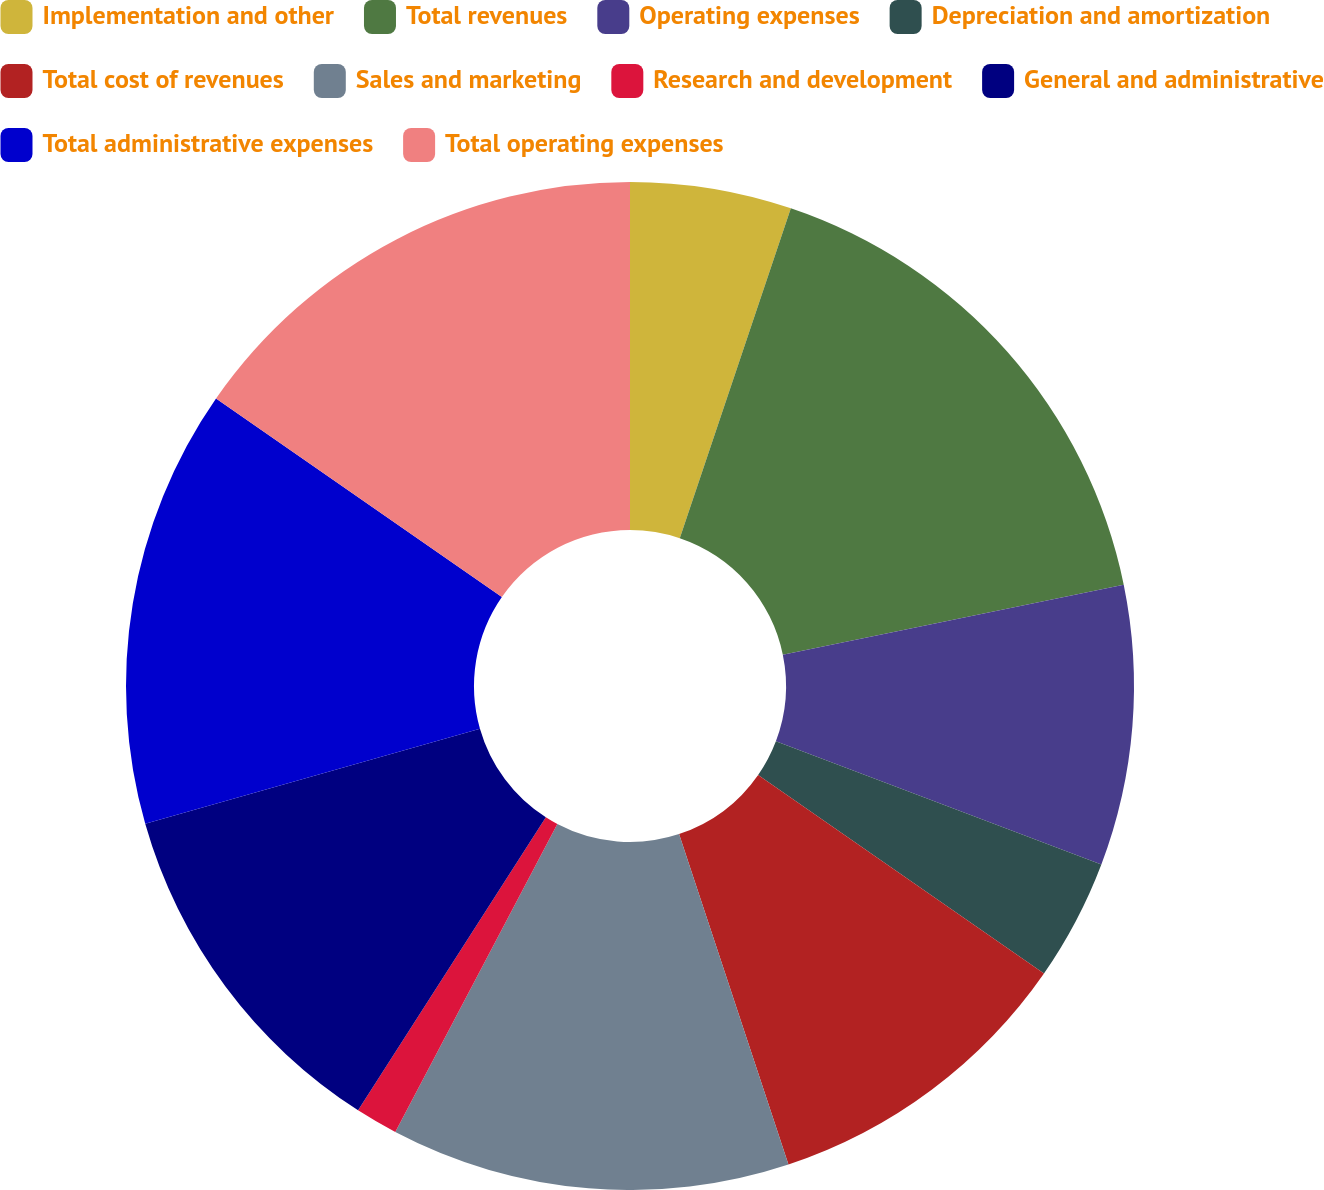Convert chart to OTSL. <chart><loc_0><loc_0><loc_500><loc_500><pie_chart><fcel>Implementation and other<fcel>Total revenues<fcel>Operating expenses<fcel>Depreciation and amortization<fcel>Total cost of revenues<fcel>Sales and marketing<fcel>Research and development<fcel>General and administrative<fcel>Total administrative expenses<fcel>Total operating expenses<nl><fcel>5.17%<fcel>16.61%<fcel>8.98%<fcel>3.9%<fcel>10.25%<fcel>12.8%<fcel>1.36%<fcel>11.52%<fcel>14.07%<fcel>15.34%<nl></chart> 